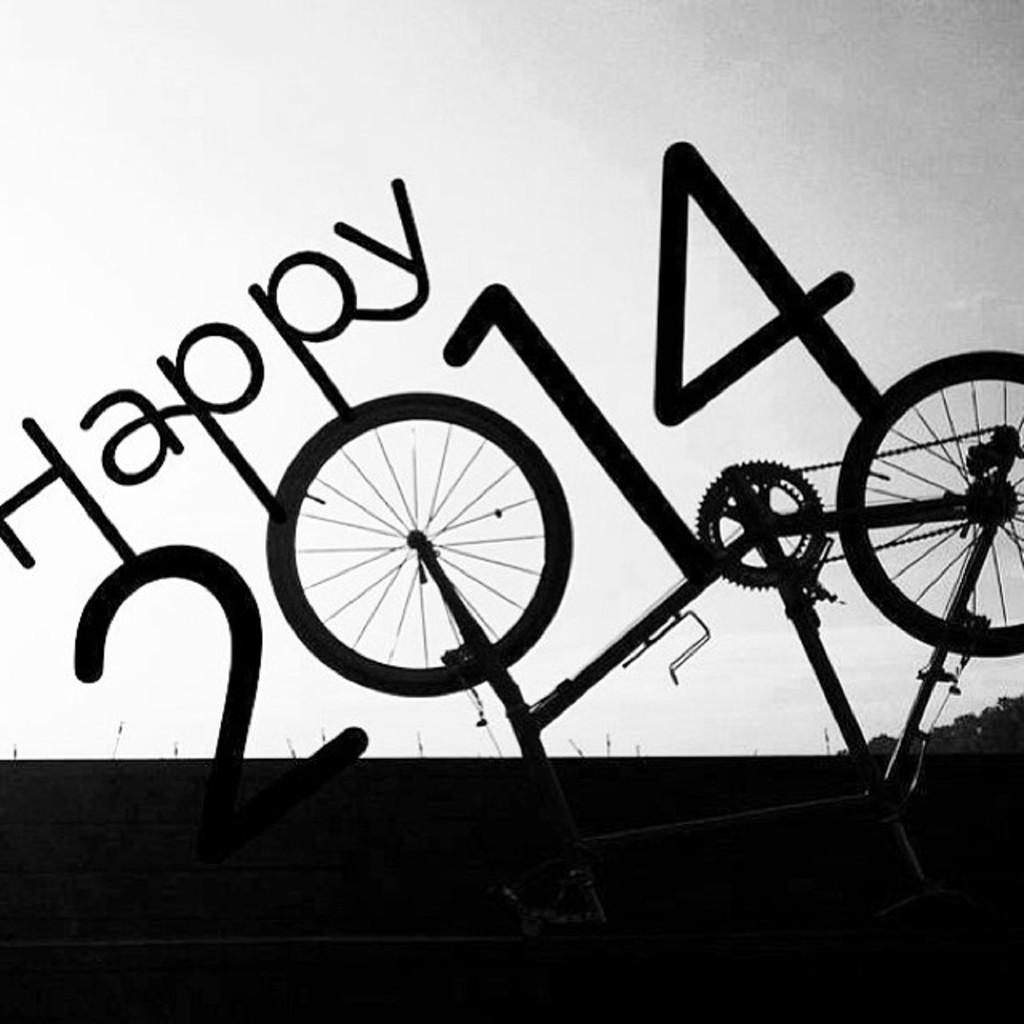In one or two sentences, can you explain what this image depicts? In this image there is a text poster written as happy 2014 with a bicycle. 